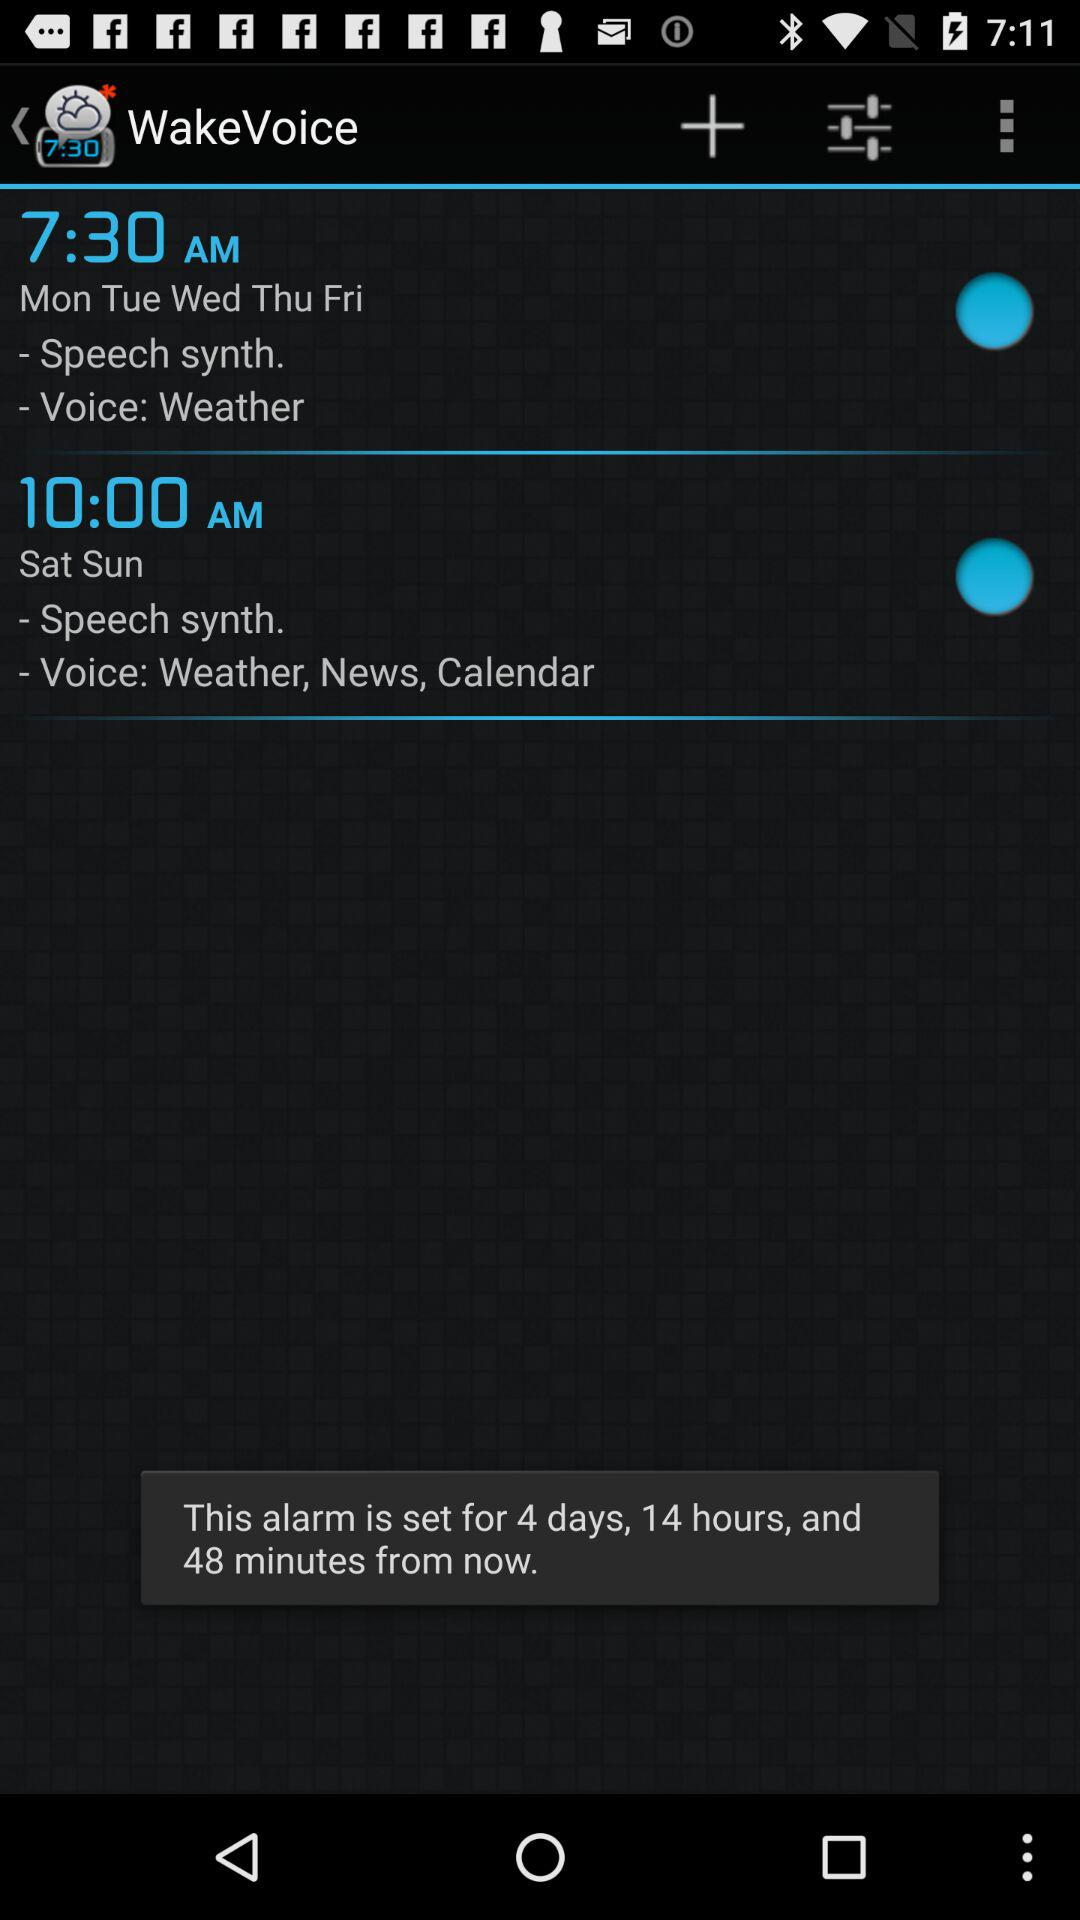What is the set alarm time for Saturday? The set alarm time for Saturday is 10:00 a.m. 